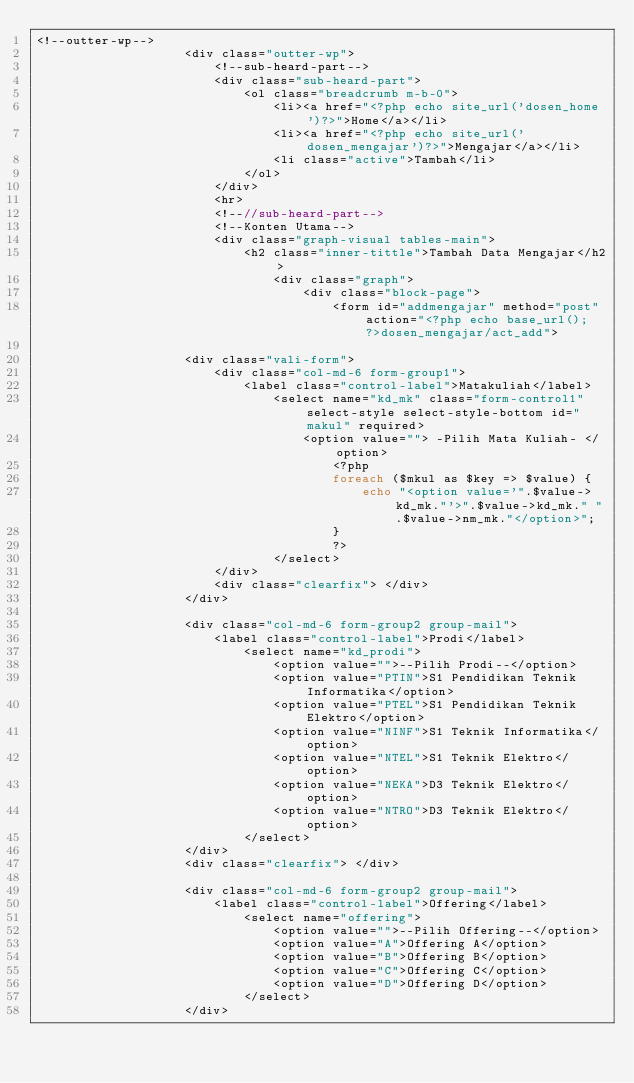<code> <loc_0><loc_0><loc_500><loc_500><_PHP_><!--outter-wp-->
					<div class="outter-wp">
						<!--sub-heard-part-->
						<div class="sub-heard-part">
							<ol class="breadcrumb m-b-0">
								<li><a href="<?php echo site_url('dosen_home')?>">Home</a></li>
								<li><a href="<?php echo site_url('dosen_mengajar')?>">Mengajar</a></li>
								<li class="active">Tambah</li>
							</ol>
						</div>
						<hr>
						<!--//sub-heard-part-->
						<!--Konten Utama-->			
						<div class="graph-visual tables-main">
							<h2 class="inner-tittle">Tambah Data Mengajar</h2>
								<div class="graph">
									<div class="block-page">
										<form id="addmengajar" method="post" action="<?php echo base_url(); ?>dosen_mengajar/act_add">
					
					<div class="vali-form">
						<div class="col-md-6 form-group1">
							<label class="control-label">Matakuliah</label>
								<select name="kd_mk" class="form-control1" select-style select-style-bottom id="makul" required>
									<option value=""> -Pilih Mata Kuliah- </option>	
										<?php 
										foreach ($mkul as $key => $value) {
											echo "<option value='".$value->kd_mk."'>".$value->kd_mk." ".$value->nm_mk."</option>";
										}
										?>
								</select>
						</div>
						<div class="clearfix"> </div>
					</div>
					
					<div class="col-md-6 form-group2 group-mail">
						<label class="control-label">Prodi</label>
							<select name="kd_prodi">
								<option value="">--Pilih Prodi--</option>
								<option value="PTIN">S1 Pendidikan Teknik Informatika</option>
								<option value="PTEL">S1 Pendidikan Teknik Elektro</option>
								<option value="NINF">S1 Teknik Informatika</option>
								<option value="NTEL">S1 Teknik Elektro</option>
								<option value="NEKA">D3 Teknik Elektro</option>
								<option value="NTRO">D3 Teknik Elektro</option>
							</select>
					</div>
					<div class="clearfix"> </div>

					<div class="col-md-6 form-group2 group-mail">
						<label class="control-label">Offering</label>
							<select name="offering">
								<option value="">--Pilih Offering--</option>
								<option value="A">Offering A</option>
								<option value="B">Offering B</option>
								<option value="C">Offering C</option>
								<option value="D">Offering D</option>
							</select>
					</div></code> 